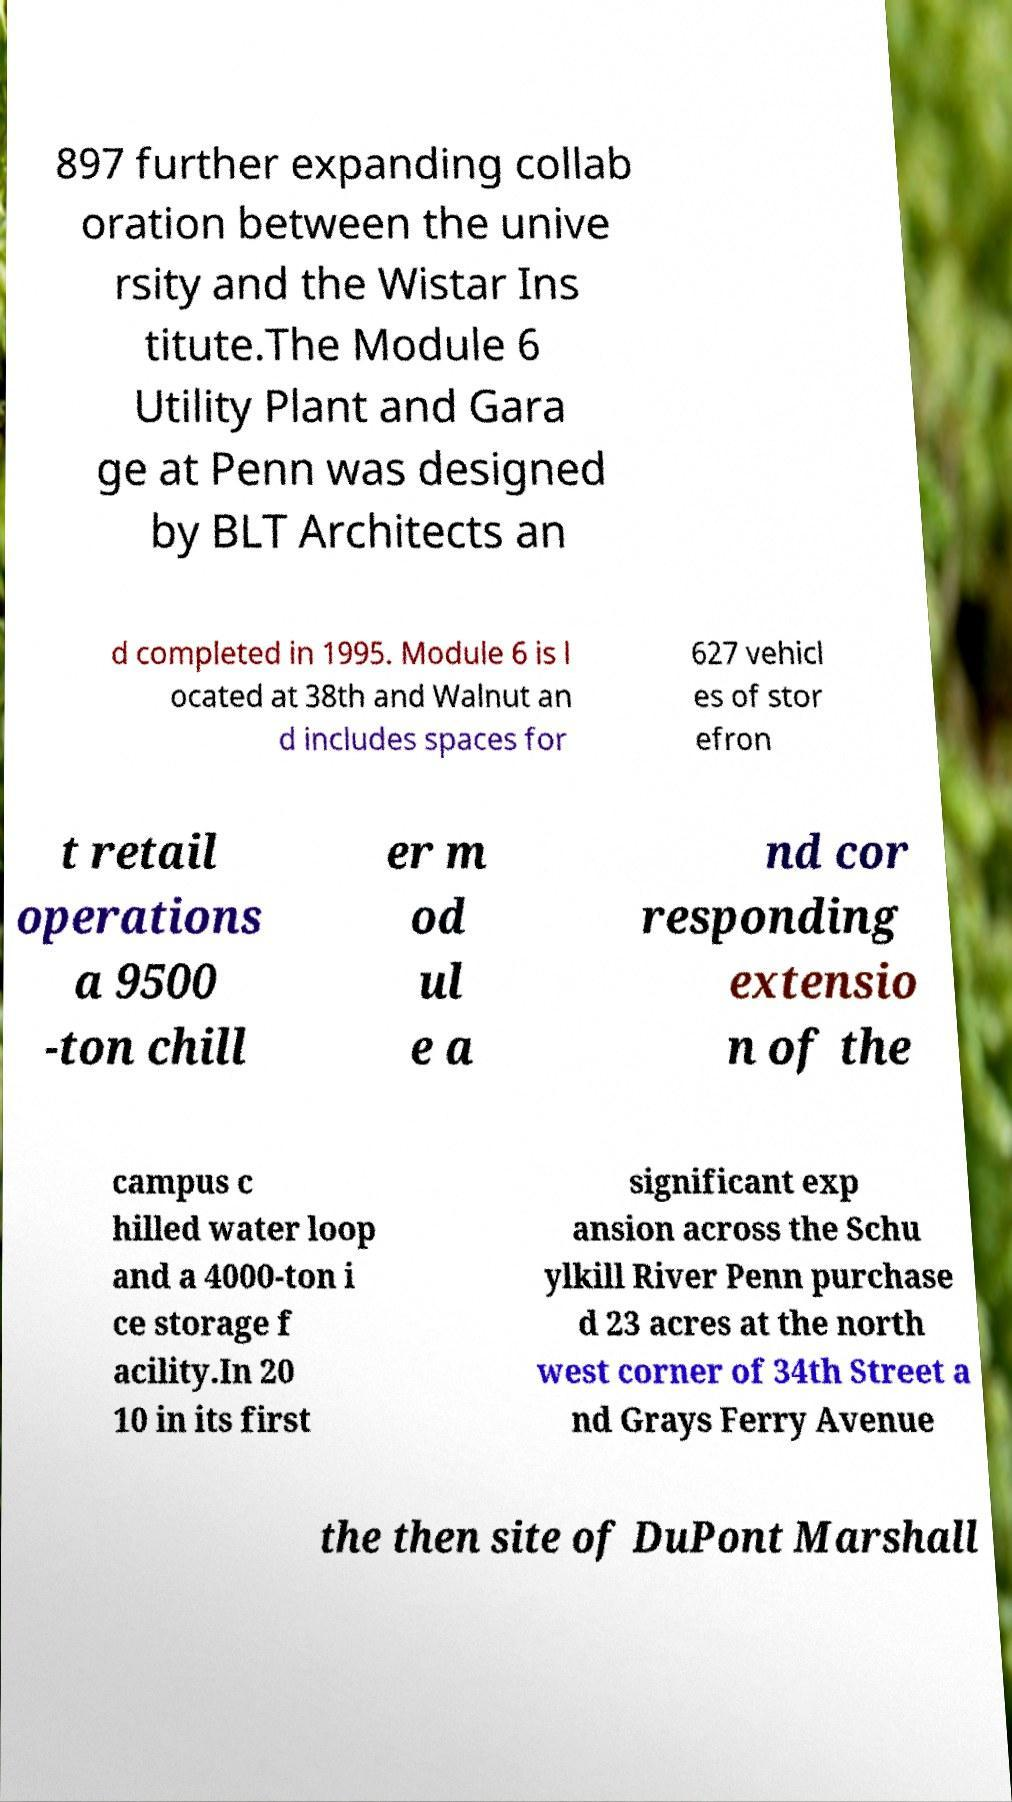What messages or text are displayed in this image? I need them in a readable, typed format. 897 further expanding collab oration between the unive rsity and the Wistar Ins titute.The Module 6 Utility Plant and Gara ge at Penn was designed by BLT Architects an d completed in 1995. Module 6 is l ocated at 38th and Walnut an d includes spaces for 627 vehicl es of stor efron t retail operations a 9500 -ton chill er m od ul e a nd cor responding extensio n of the campus c hilled water loop and a 4000-ton i ce storage f acility.In 20 10 in its first significant exp ansion across the Schu ylkill River Penn purchase d 23 acres at the north west corner of 34th Street a nd Grays Ferry Avenue the then site of DuPont Marshall 